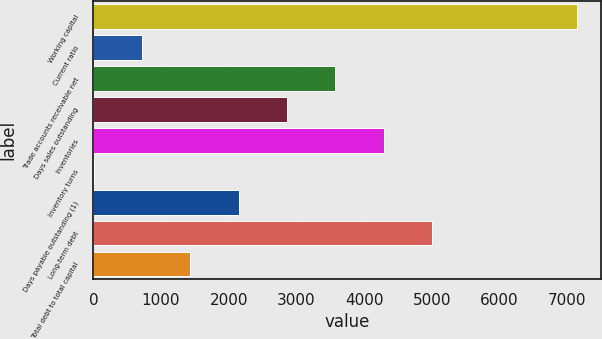Convert chart to OTSL. <chart><loc_0><loc_0><loc_500><loc_500><bar_chart><fcel>Working capital<fcel>Current ratio<fcel>Trade accounts receivable net<fcel>Days sales outstanding<fcel>Inventories<fcel>Inventory turns<fcel>Days payable outstanding (1)<fcel>Long-term debt<fcel>Total debt to total capital<nl><fcel>7145<fcel>717.74<fcel>3574.3<fcel>2860.16<fcel>4288.44<fcel>3.6<fcel>2146.02<fcel>5002.58<fcel>1431.88<nl></chart> 